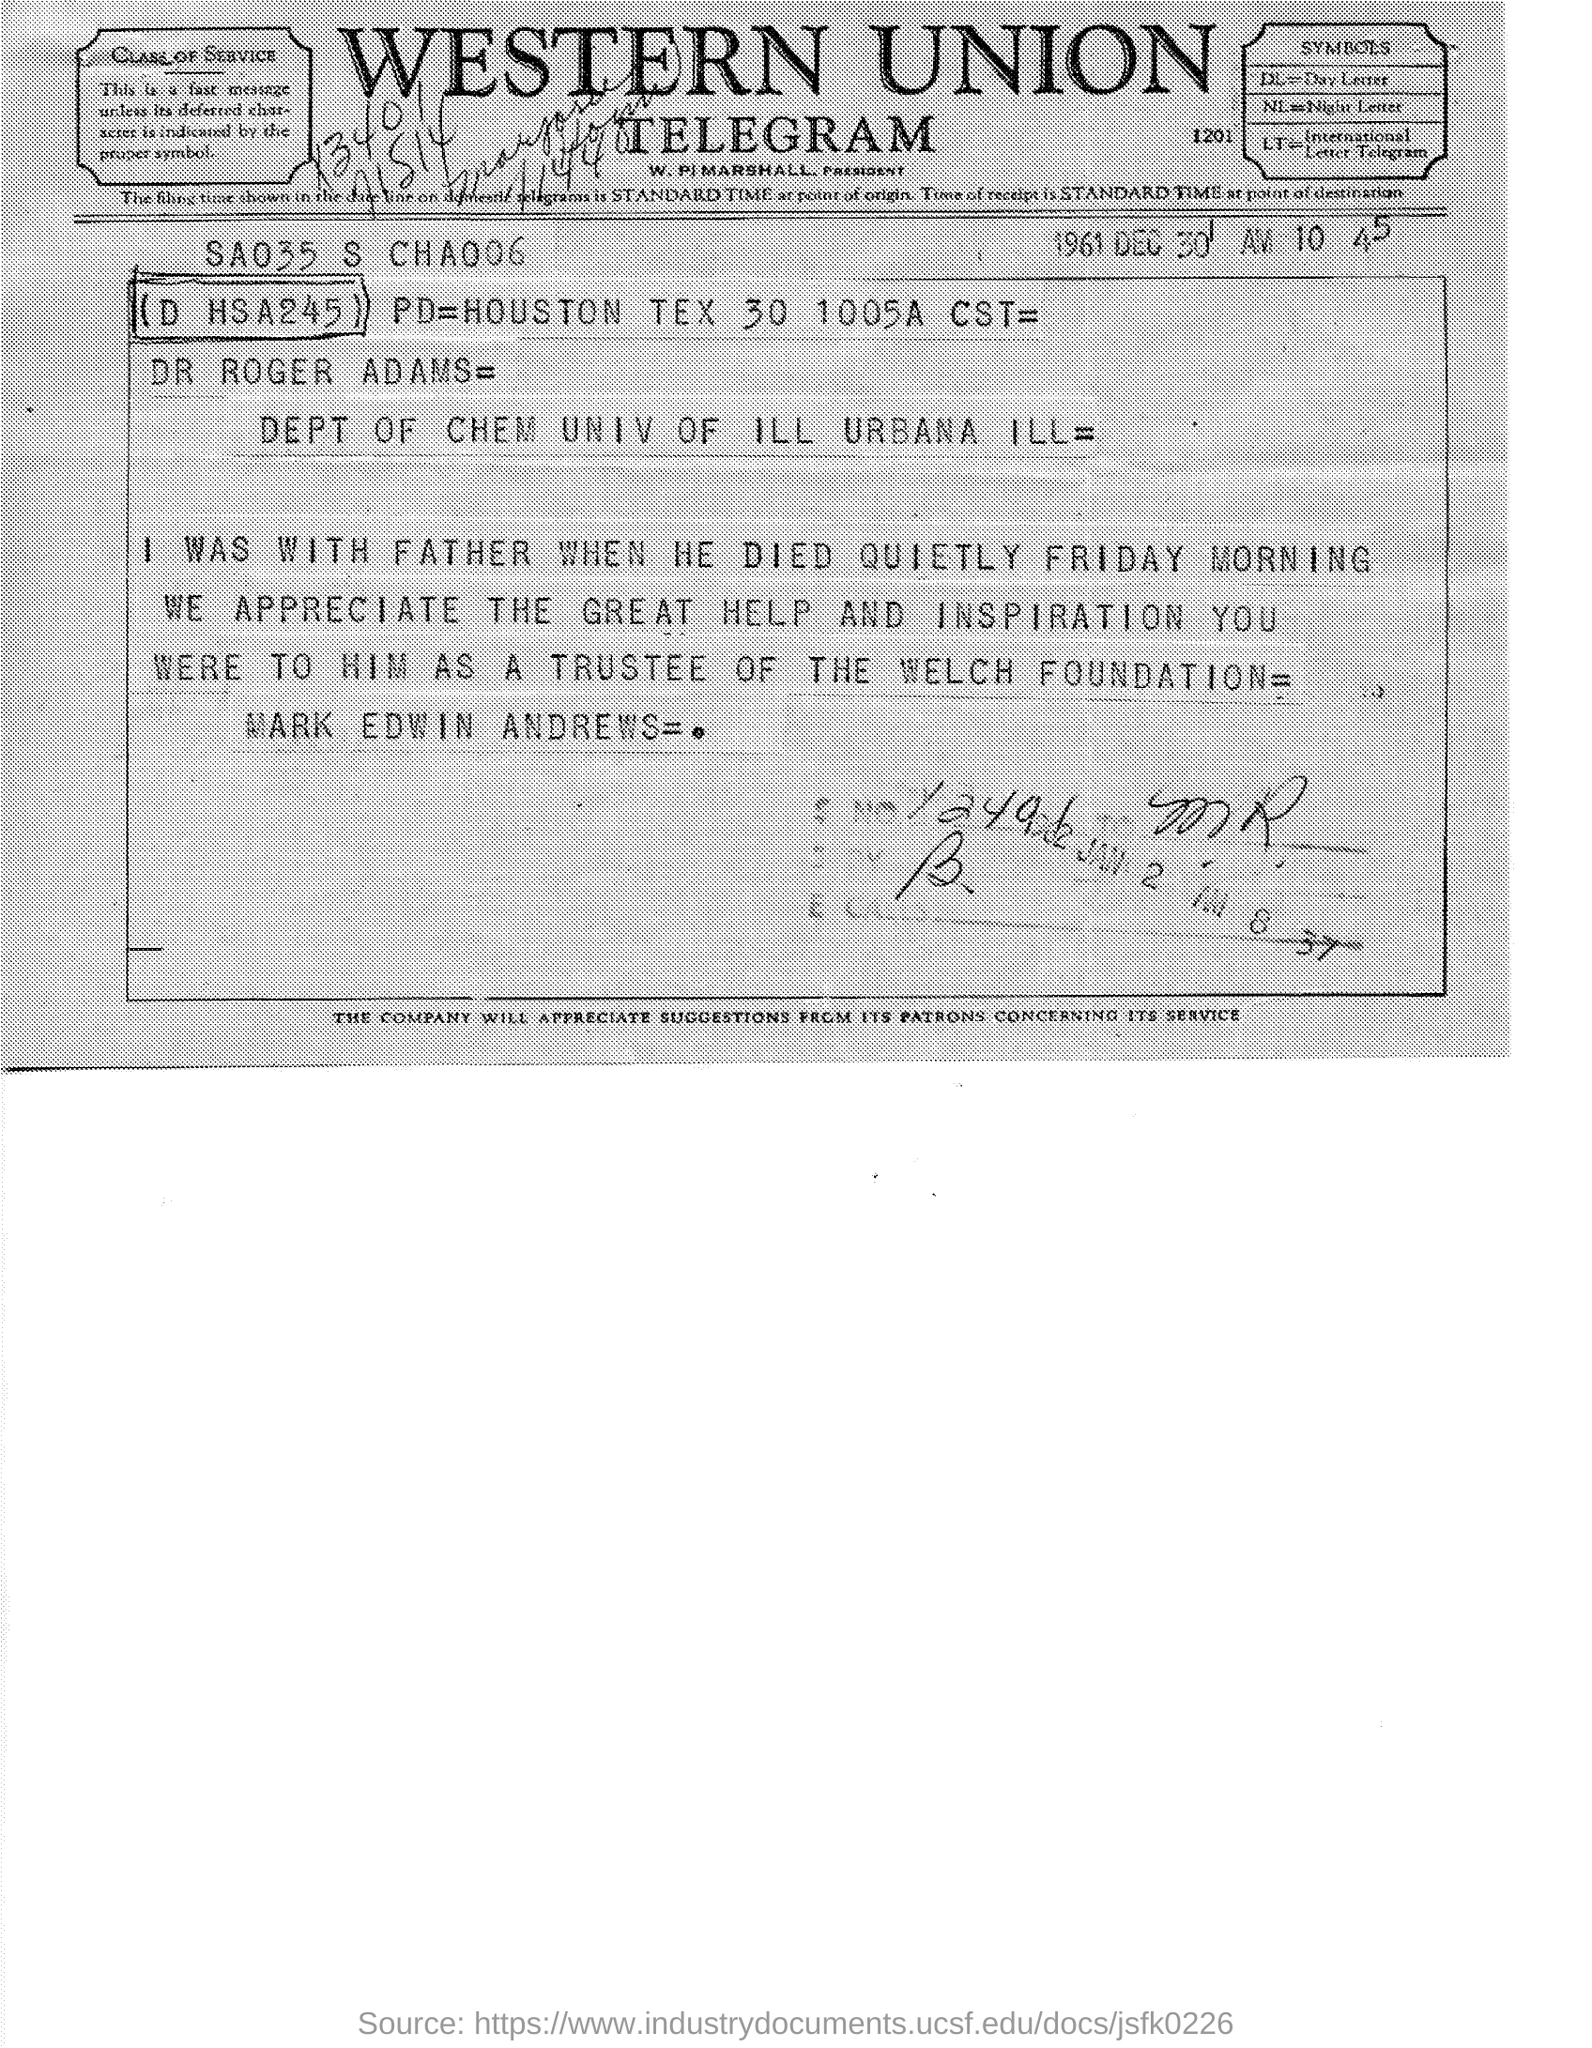What type of document is this?
Make the answer very short. Telegram. When is the document dated?
Your answer should be very brief. 1961 DEC 30. Which firm is mentioned at the top of the page?
Your answer should be compact. Western Union. 